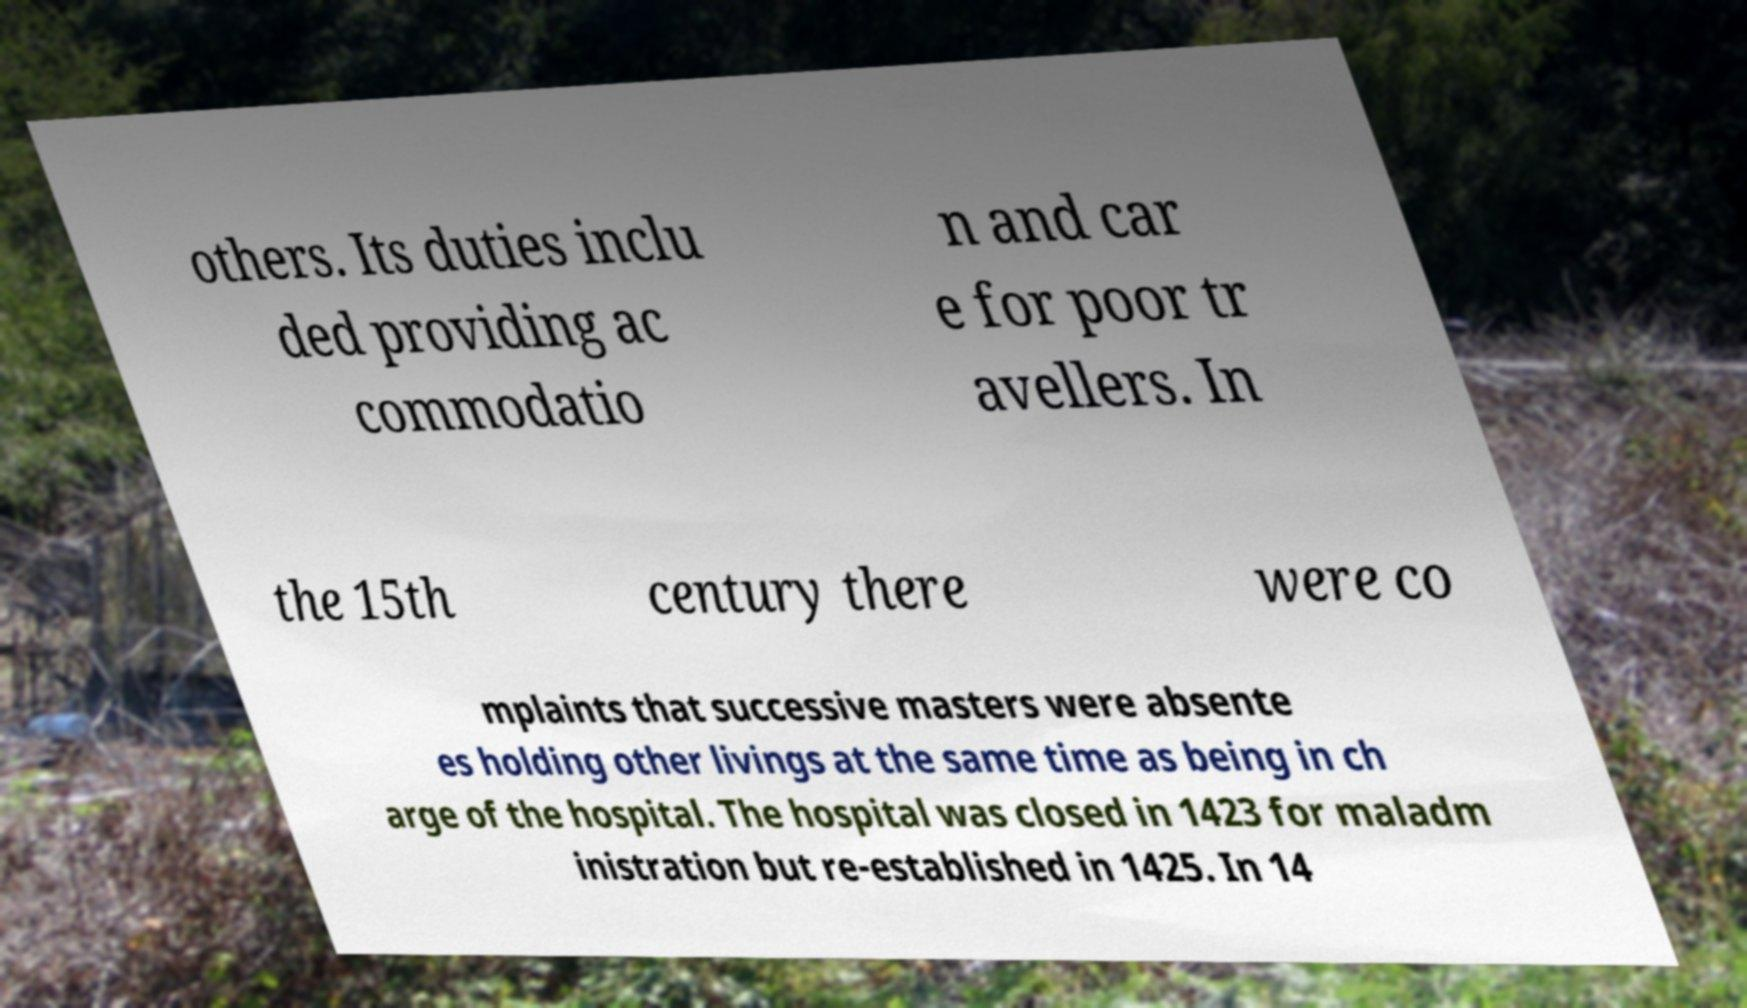I need the written content from this picture converted into text. Can you do that? others. Its duties inclu ded providing ac commodatio n and car e for poor tr avellers. In the 15th century there were co mplaints that successive masters were absente es holding other livings at the same time as being in ch arge of the hospital. The hospital was closed in 1423 for maladm inistration but re-established in 1425. In 14 